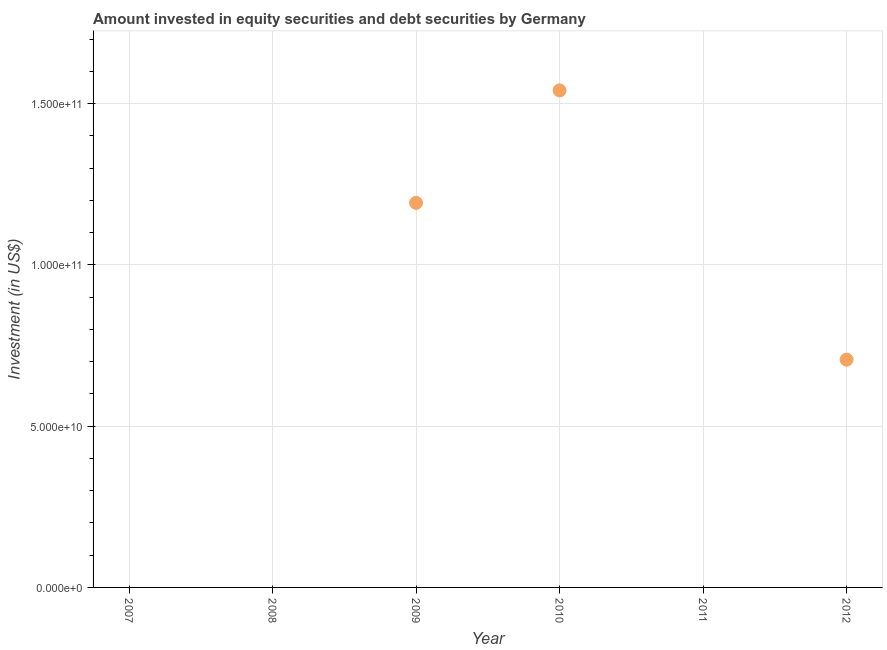What is the portfolio investment in 2012?
Make the answer very short. 7.06e+1. Across all years, what is the maximum portfolio investment?
Ensure brevity in your answer.  1.54e+11. In which year was the portfolio investment maximum?
Offer a very short reply. 2010. What is the sum of the portfolio investment?
Ensure brevity in your answer.  3.44e+11. What is the average portfolio investment per year?
Offer a terse response. 5.73e+1. What is the median portfolio investment?
Offer a terse response. 3.53e+1. In how many years, is the portfolio investment greater than 40000000000 US$?
Provide a short and direct response. 3. What is the ratio of the portfolio investment in 2009 to that in 2010?
Make the answer very short. 0.77. Is the portfolio investment in 2009 less than that in 2010?
Your answer should be very brief. Yes. What is the difference between the highest and the second highest portfolio investment?
Your answer should be compact. 3.49e+1. What is the difference between the highest and the lowest portfolio investment?
Ensure brevity in your answer.  1.54e+11. Are the values on the major ticks of Y-axis written in scientific E-notation?
Keep it short and to the point. Yes. Does the graph contain any zero values?
Provide a succinct answer. Yes. Does the graph contain grids?
Make the answer very short. Yes. What is the title of the graph?
Make the answer very short. Amount invested in equity securities and debt securities by Germany. What is the label or title of the Y-axis?
Provide a short and direct response. Investment (in US$). What is the Investment (in US$) in 2009?
Offer a very short reply. 1.19e+11. What is the Investment (in US$) in 2010?
Make the answer very short. 1.54e+11. What is the Investment (in US$) in 2012?
Your response must be concise. 7.06e+1. What is the difference between the Investment (in US$) in 2009 and 2010?
Offer a terse response. -3.49e+1. What is the difference between the Investment (in US$) in 2009 and 2012?
Provide a succinct answer. 4.86e+1. What is the difference between the Investment (in US$) in 2010 and 2012?
Ensure brevity in your answer.  8.35e+1. What is the ratio of the Investment (in US$) in 2009 to that in 2010?
Offer a very short reply. 0.77. What is the ratio of the Investment (in US$) in 2009 to that in 2012?
Provide a succinct answer. 1.69. What is the ratio of the Investment (in US$) in 2010 to that in 2012?
Make the answer very short. 2.18. 